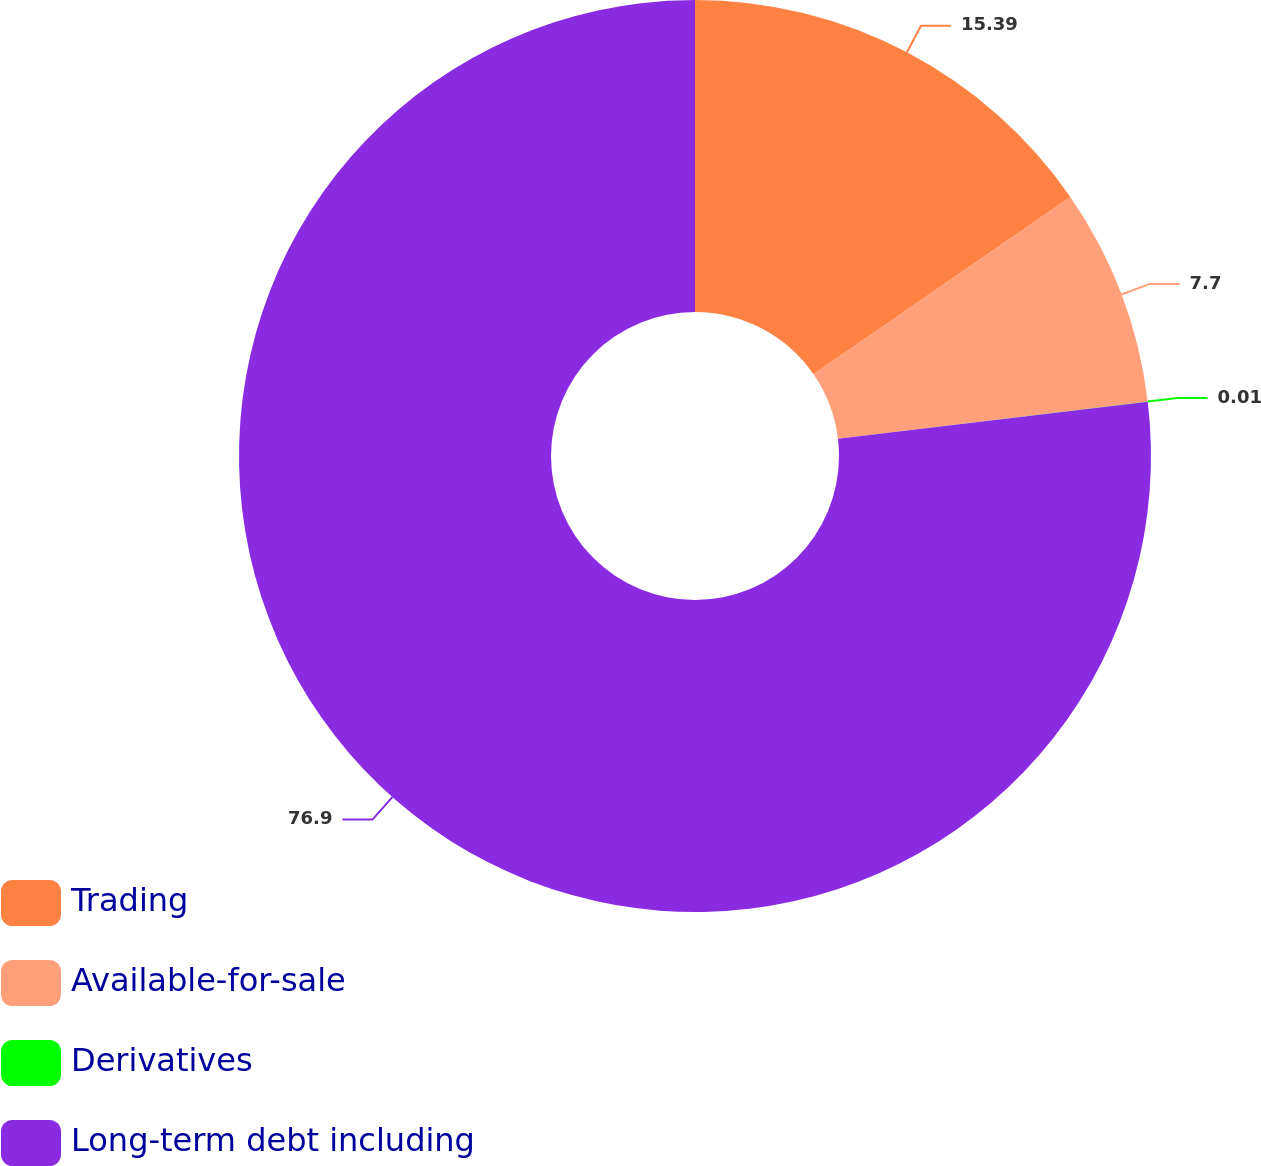Convert chart to OTSL. <chart><loc_0><loc_0><loc_500><loc_500><pie_chart><fcel>Trading<fcel>Available-for-sale<fcel>Derivatives<fcel>Long-term debt including<nl><fcel>15.39%<fcel>7.7%<fcel>0.01%<fcel>76.9%<nl></chart> 